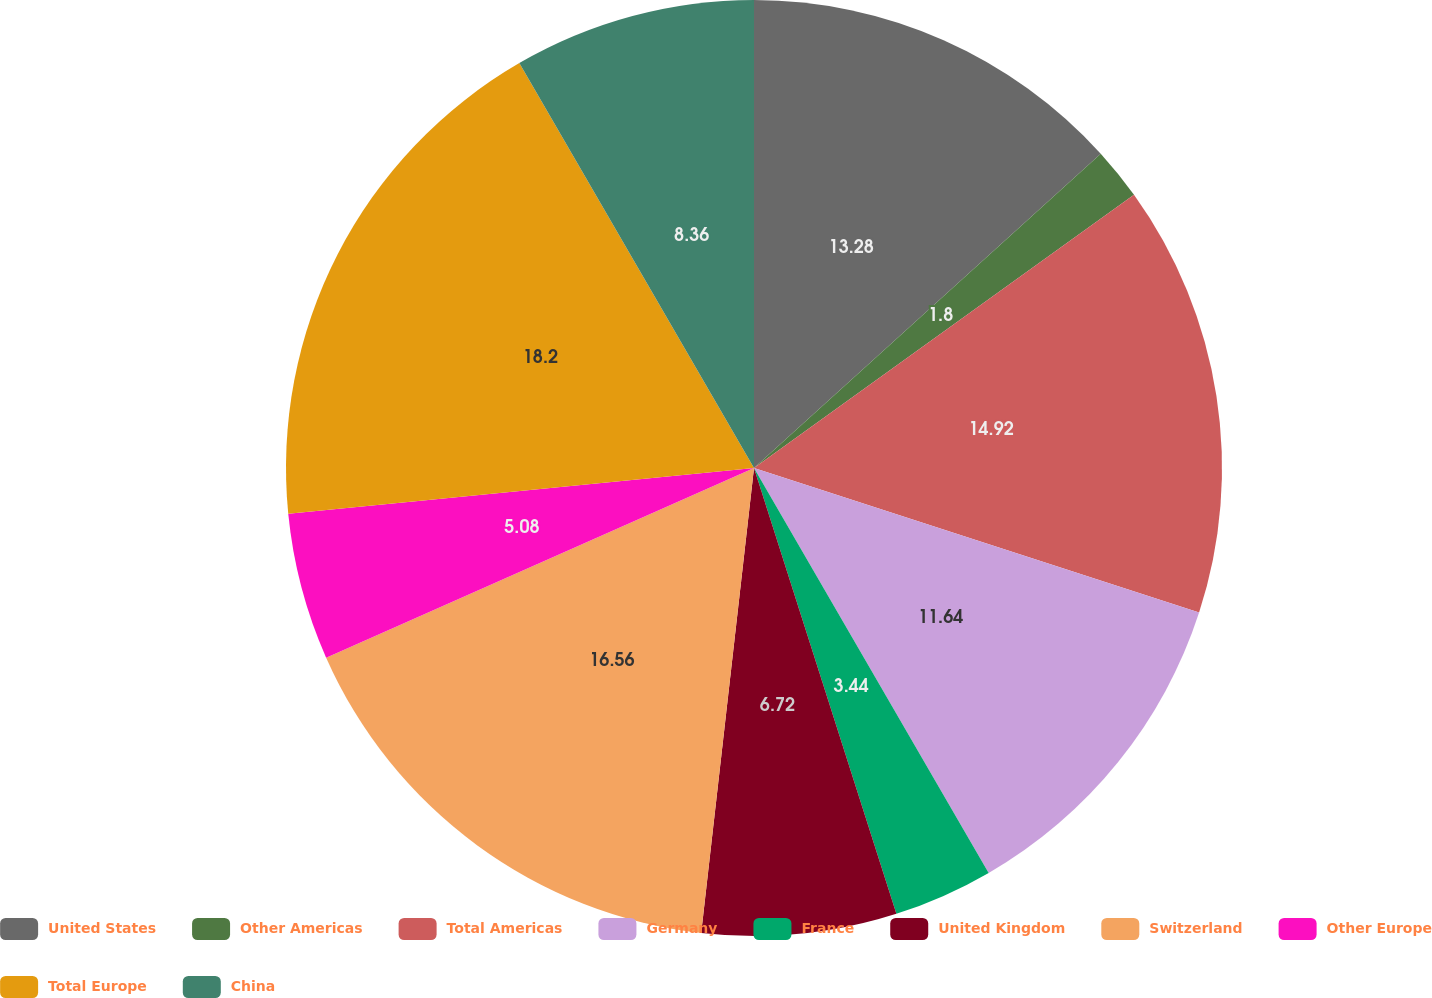Convert chart. <chart><loc_0><loc_0><loc_500><loc_500><pie_chart><fcel>United States<fcel>Other Americas<fcel>Total Americas<fcel>Germany<fcel>France<fcel>United Kingdom<fcel>Switzerland<fcel>Other Europe<fcel>Total Europe<fcel>China<nl><fcel>13.28%<fcel>1.8%<fcel>14.92%<fcel>11.64%<fcel>3.44%<fcel>6.72%<fcel>16.56%<fcel>5.08%<fcel>18.2%<fcel>8.36%<nl></chart> 